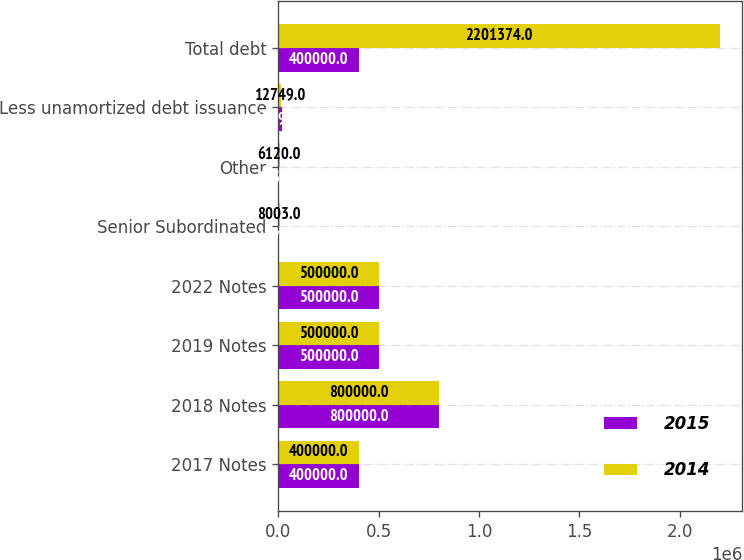<chart> <loc_0><loc_0><loc_500><loc_500><stacked_bar_chart><ecel><fcel>2017 Notes<fcel>2018 Notes<fcel>2019 Notes<fcel>2022 Notes<fcel>Senior Subordinated<fcel>Other<fcel>Less unamortized debt issuance<fcel>Total debt<nl><fcel>2015<fcel>400000<fcel>800000<fcel>500000<fcel>500000<fcel>4179<fcel>4435<fcel>17392<fcel>400000<nl><fcel>2014<fcel>400000<fcel>800000<fcel>500000<fcel>500000<fcel>8003<fcel>6120<fcel>12749<fcel>2.20137e+06<nl></chart> 